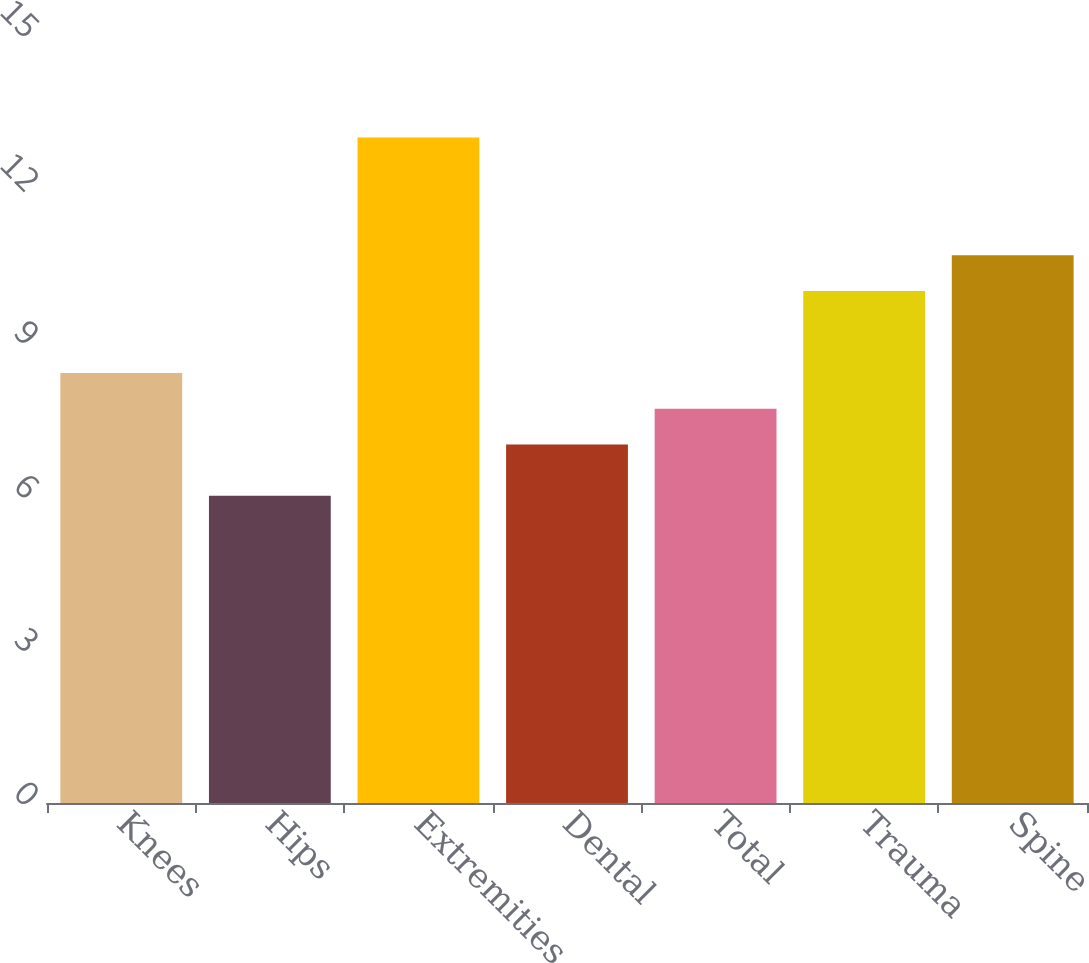Convert chart. <chart><loc_0><loc_0><loc_500><loc_500><bar_chart><fcel>Knees<fcel>Hips<fcel>Extremities<fcel>Dental<fcel>Total<fcel>Trauma<fcel>Spine<nl><fcel>8.4<fcel>6<fcel>13<fcel>7<fcel>7.7<fcel>10<fcel>10.7<nl></chart> 